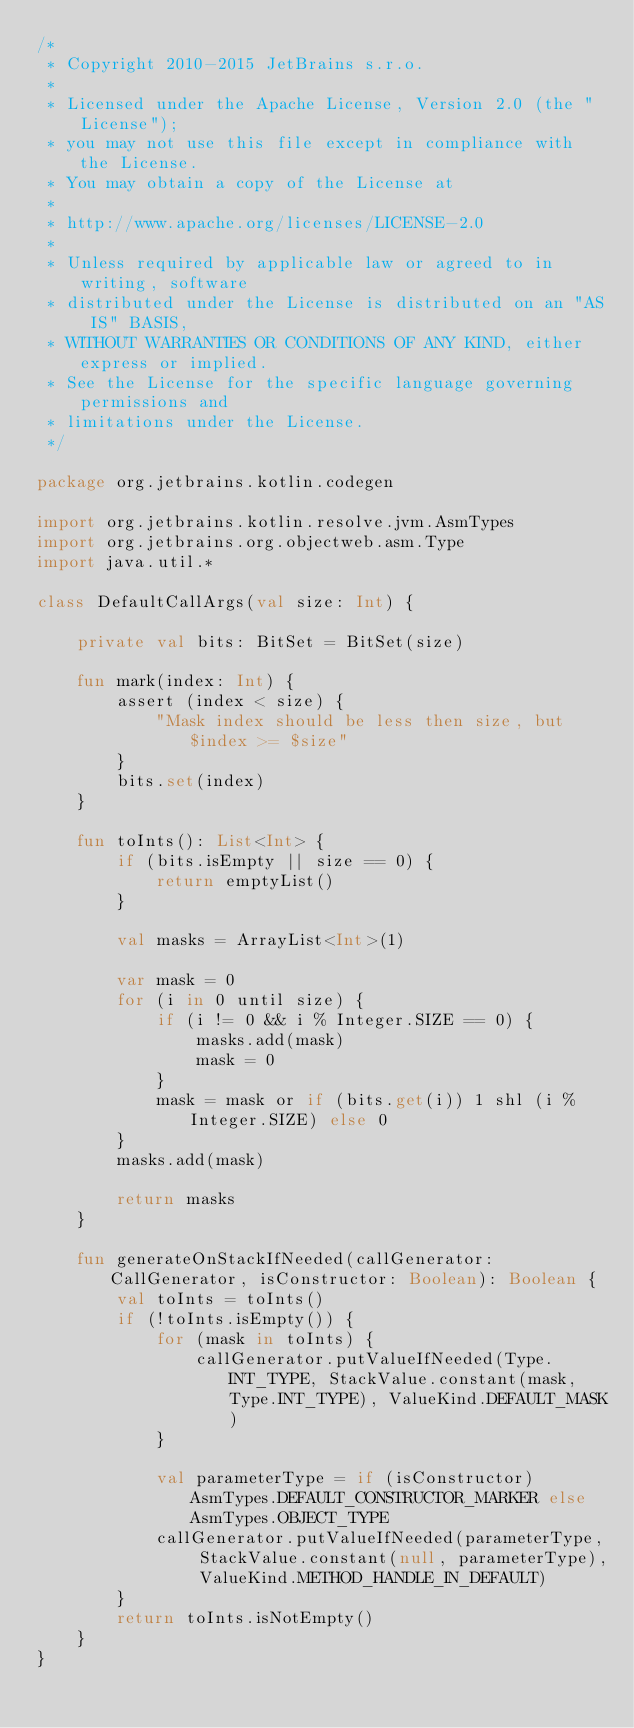Convert code to text. <code><loc_0><loc_0><loc_500><loc_500><_Kotlin_>/*
 * Copyright 2010-2015 JetBrains s.r.o.
 *
 * Licensed under the Apache License, Version 2.0 (the "License");
 * you may not use this file except in compliance with the License.
 * You may obtain a copy of the License at
 *
 * http://www.apache.org/licenses/LICENSE-2.0
 *
 * Unless required by applicable law or agreed to in writing, software
 * distributed under the License is distributed on an "AS IS" BASIS,
 * WITHOUT WARRANTIES OR CONDITIONS OF ANY KIND, either express or implied.
 * See the License for the specific language governing permissions and
 * limitations under the License.
 */

package org.jetbrains.kotlin.codegen

import org.jetbrains.kotlin.resolve.jvm.AsmTypes
import org.jetbrains.org.objectweb.asm.Type
import java.util.*

class DefaultCallArgs(val size: Int) {

    private val bits: BitSet = BitSet(size)

    fun mark(index: Int) {
        assert (index < size) {
            "Mask index should be less then size, but $index >= $size"
        }
        bits.set(index)
    }

    fun toInts(): List<Int> {
        if (bits.isEmpty || size == 0) {
            return emptyList()
        }

        val masks = ArrayList<Int>(1)

        var mask = 0
        for (i in 0 until size) {
            if (i != 0 && i % Integer.SIZE == 0) {
                masks.add(mask)
                mask = 0
            }
            mask = mask or if (bits.get(i)) 1 shl (i % Integer.SIZE) else 0
        }
        masks.add(mask)

        return masks
    }

    fun generateOnStackIfNeeded(callGenerator: CallGenerator, isConstructor: Boolean): Boolean {
        val toInts = toInts()
        if (!toInts.isEmpty()) {
            for (mask in toInts) {
                callGenerator.putValueIfNeeded(Type.INT_TYPE, StackValue.constant(mask, Type.INT_TYPE), ValueKind.DEFAULT_MASK)
            }

            val parameterType = if (isConstructor) AsmTypes.DEFAULT_CONSTRUCTOR_MARKER else AsmTypes.OBJECT_TYPE
            callGenerator.putValueIfNeeded(parameterType, StackValue.constant(null, parameterType), ValueKind.METHOD_HANDLE_IN_DEFAULT)
        }
        return toInts.isNotEmpty()
    }
}</code> 